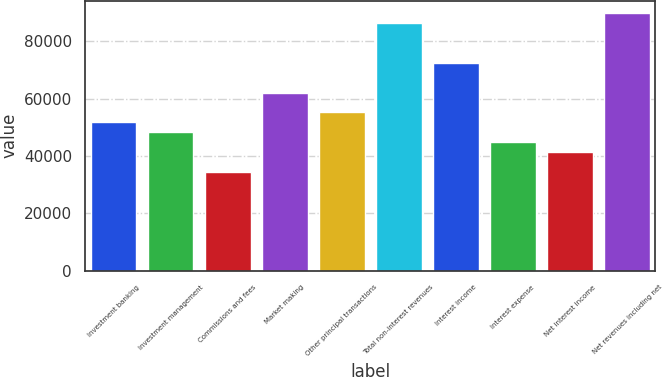<chart> <loc_0><loc_0><loc_500><loc_500><bar_chart><fcel>Investment banking<fcel>Investment management<fcel>Commissions and fees<fcel>Market making<fcel>Other principal transactions<fcel>Total non-interest revenues<fcel>Interest income<fcel>Interest expense<fcel>Net interest income<fcel>Net revenues including net<nl><fcel>51783.4<fcel>48332.3<fcel>34528<fcel>62136.7<fcel>55234.5<fcel>86294.3<fcel>72490<fcel>44881.2<fcel>41430.2<fcel>89745.4<nl></chart> 